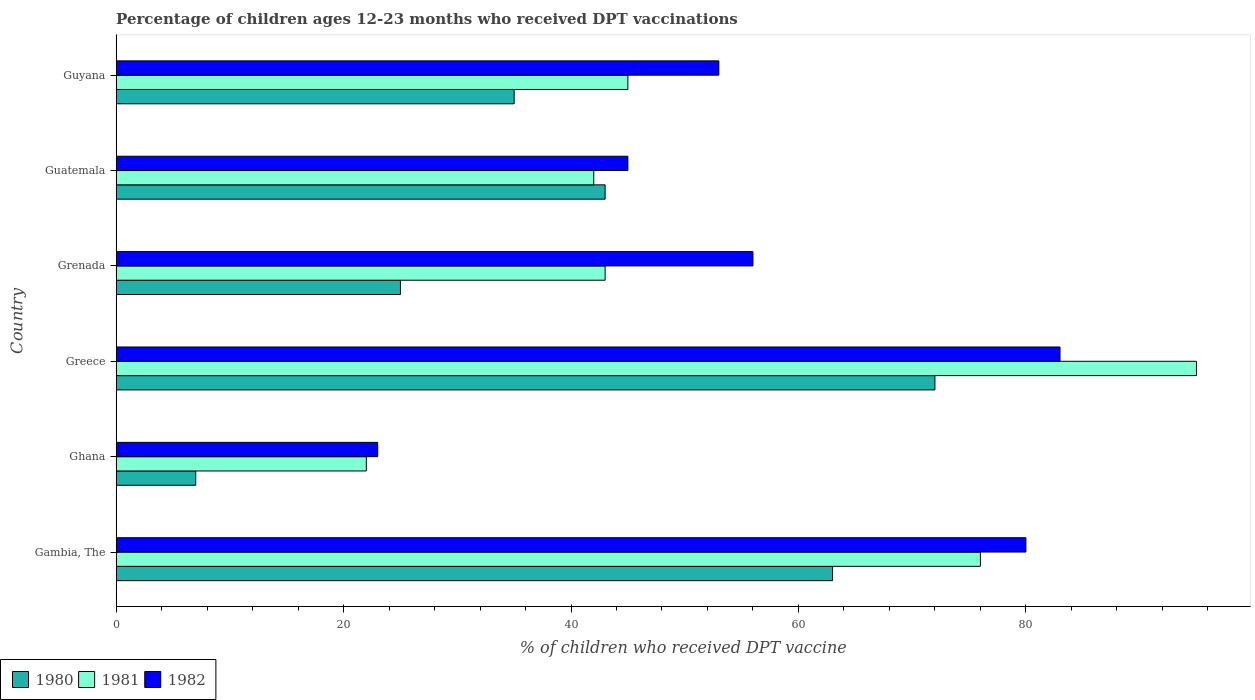How many groups of bars are there?
Make the answer very short. 6. Are the number of bars per tick equal to the number of legend labels?
Your answer should be very brief. Yes. Are the number of bars on each tick of the Y-axis equal?
Keep it short and to the point. Yes. How many bars are there on the 6th tick from the top?
Your answer should be compact. 3. What is the label of the 3rd group of bars from the top?
Give a very brief answer. Grenada. In how many cases, is the number of bars for a given country not equal to the number of legend labels?
Provide a succinct answer. 0. Across all countries, what is the maximum percentage of children who received DPT vaccination in 1982?
Offer a terse response. 83. Across all countries, what is the minimum percentage of children who received DPT vaccination in 1980?
Offer a terse response. 7. In which country was the percentage of children who received DPT vaccination in 1982 minimum?
Offer a terse response. Ghana. What is the total percentage of children who received DPT vaccination in 1980 in the graph?
Ensure brevity in your answer.  245. What is the difference between the percentage of children who received DPT vaccination in 1980 in Guyana and the percentage of children who received DPT vaccination in 1981 in Ghana?
Give a very brief answer. 13. What is the average percentage of children who received DPT vaccination in 1982 per country?
Provide a short and direct response. 56.67. What is the ratio of the percentage of children who received DPT vaccination in 1982 in Greece to that in Guyana?
Your answer should be very brief. 1.57. Is the percentage of children who received DPT vaccination in 1982 in Ghana less than that in Guatemala?
Provide a succinct answer. Yes. Is the difference between the percentage of children who received DPT vaccination in 1982 in Ghana and Greece greater than the difference between the percentage of children who received DPT vaccination in 1980 in Ghana and Greece?
Ensure brevity in your answer.  Yes. What is the difference between the highest and the lowest percentage of children who received DPT vaccination in 1981?
Your response must be concise. 73. In how many countries, is the percentage of children who received DPT vaccination in 1981 greater than the average percentage of children who received DPT vaccination in 1981 taken over all countries?
Your answer should be compact. 2. Is the sum of the percentage of children who received DPT vaccination in 1982 in Gambia, The and Guyana greater than the maximum percentage of children who received DPT vaccination in 1981 across all countries?
Your response must be concise. Yes. What does the 2nd bar from the top in Gambia, The represents?
Your answer should be compact. 1981. What does the 2nd bar from the bottom in Guatemala represents?
Your response must be concise. 1981. Is it the case that in every country, the sum of the percentage of children who received DPT vaccination in 1981 and percentage of children who received DPT vaccination in 1982 is greater than the percentage of children who received DPT vaccination in 1980?
Your response must be concise. Yes. How many bars are there?
Keep it short and to the point. 18. Are all the bars in the graph horizontal?
Make the answer very short. Yes. What is the difference between two consecutive major ticks on the X-axis?
Give a very brief answer. 20. Are the values on the major ticks of X-axis written in scientific E-notation?
Ensure brevity in your answer.  No. How are the legend labels stacked?
Provide a succinct answer. Horizontal. What is the title of the graph?
Your answer should be compact. Percentage of children ages 12-23 months who received DPT vaccinations. What is the label or title of the X-axis?
Your answer should be very brief. % of children who received DPT vaccine. What is the label or title of the Y-axis?
Provide a short and direct response. Country. What is the % of children who received DPT vaccine of 1981 in Gambia, The?
Offer a terse response. 76. What is the % of children who received DPT vaccine in 1982 in Gambia, The?
Provide a succinct answer. 80. What is the % of children who received DPT vaccine in 1980 in Ghana?
Make the answer very short. 7. What is the % of children who received DPT vaccine in 1981 in Ghana?
Keep it short and to the point. 22. What is the % of children who received DPT vaccine of 1982 in Ghana?
Offer a very short reply. 23. What is the % of children who received DPT vaccine in 1980 in Greece?
Your answer should be compact. 72. What is the % of children who received DPT vaccine in 1982 in Greece?
Give a very brief answer. 83. What is the % of children who received DPT vaccine of 1980 in Guatemala?
Your answer should be very brief. 43. What is the % of children who received DPT vaccine of 1982 in Guatemala?
Make the answer very short. 45. What is the % of children who received DPT vaccine in 1980 in Guyana?
Ensure brevity in your answer.  35. What is the % of children who received DPT vaccine in 1982 in Guyana?
Make the answer very short. 53. Across all countries, what is the maximum % of children who received DPT vaccine in 1980?
Offer a terse response. 72. Across all countries, what is the minimum % of children who received DPT vaccine of 1980?
Provide a succinct answer. 7. Across all countries, what is the minimum % of children who received DPT vaccine of 1981?
Keep it short and to the point. 22. Across all countries, what is the minimum % of children who received DPT vaccine in 1982?
Your answer should be compact. 23. What is the total % of children who received DPT vaccine in 1980 in the graph?
Provide a short and direct response. 245. What is the total % of children who received DPT vaccine of 1981 in the graph?
Make the answer very short. 323. What is the total % of children who received DPT vaccine of 1982 in the graph?
Ensure brevity in your answer.  340. What is the difference between the % of children who received DPT vaccine of 1980 in Gambia, The and that in Ghana?
Make the answer very short. 56. What is the difference between the % of children who received DPT vaccine of 1982 in Gambia, The and that in Ghana?
Ensure brevity in your answer.  57. What is the difference between the % of children who received DPT vaccine in 1982 in Gambia, The and that in Grenada?
Provide a short and direct response. 24. What is the difference between the % of children who received DPT vaccine in 1980 in Gambia, The and that in Guatemala?
Make the answer very short. 20. What is the difference between the % of children who received DPT vaccine in 1981 in Gambia, The and that in Guatemala?
Make the answer very short. 34. What is the difference between the % of children who received DPT vaccine in 1980 in Gambia, The and that in Guyana?
Your answer should be compact. 28. What is the difference between the % of children who received DPT vaccine of 1980 in Ghana and that in Greece?
Make the answer very short. -65. What is the difference between the % of children who received DPT vaccine of 1981 in Ghana and that in Greece?
Keep it short and to the point. -73. What is the difference between the % of children who received DPT vaccine in 1982 in Ghana and that in Greece?
Provide a succinct answer. -60. What is the difference between the % of children who received DPT vaccine in 1980 in Ghana and that in Grenada?
Provide a short and direct response. -18. What is the difference between the % of children who received DPT vaccine of 1981 in Ghana and that in Grenada?
Offer a terse response. -21. What is the difference between the % of children who received DPT vaccine in 1982 in Ghana and that in Grenada?
Your answer should be compact. -33. What is the difference between the % of children who received DPT vaccine in 1980 in Ghana and that in Guatemala?
Give a very brief answer. -36. What is the difference between the % of children who received DPT vaccine in 1981 in Ghana and that in Guatemala?
Your answer should be compact. -20. What is the difference between the % of children who received DPT vaccine in 1982 in Ghana and that in Guatemala?
Keep it short and to the point. -22. What is the difference between the % of children who received DPT vaccine of 1980 in Ghana and that in Guyana?
Keep it short and to the point. -28. What is the difference between the % of children who received DPT vaccine in 1981 in Ghana and that in Guyana?
Make the answer very short. -23. What is the difference between the % of children who received DPT vaccine in 1981 in Greece and that in Grenada?
Provide a short and direct response. 52. What is the difference between the % of children who received DPT vaccine in 1982 in Greece and that in Guatemala?
Your response must be concise. 38. What is the difference between the % of children who received DPT vaccine of 1980 in Grenada and that in Guatemala?
Your answer should be compact. -18. What is the difference between the % of children who received DPT vaccine of 1982 in Grenada and that in Guatemala?
Your answer should be very brief. 11. What is the difference between the % of children who received DPT vaccine of 1981 in Grenada and that in Guyana?
Your answer should be compact. -2. What is the difference between the % of children who received DPT vaccine in 1982 in Grenada and that in Guyana?
Your answer should be compact. 3. What is the difference between the % of children who received DPT vaccine in 1980 in Guatemala and that in Guyana?
Your response must be concise. 8. What is the difference between the % of children who received DPT vaccine in 1982 in Guatemala and that in Guyana?
Make the answer very short. -8. What is the difference between the % of children who received DPT vaccine of 1980 in Gambia, The and the % of children who received DPT vaccine of 1981 in Greece?
Provide a succinct answer. -32. What is the difference between the % of children who received DPT vaccine in 1980 in Gambia, The and the % of children who received DPT vaccine in 1981 in Grenada?
Your answer should be compact. 20. What is the difference between the % of children who received DPT vaccine of 1980 in Gambia, The and the % of children who received DPT vaccine of 1982 in Grenada?
Provide a succinct answer. 7. What is the difference between the % of children who received DPT vaccine in 1981 in Gambia, The and the % of children who received DPT vaccine in 1982 in Grenada?
Make the answer very short. 20. What is the difference between the % of children who received DPT vaccine of 1980 in Gambia, The and the % of children who received DPT vaccine of 1982 in Guyana?
Your answer should be very brief. 10. What is the difference between the % of children who received DPT vaccine in 1981 in Gambia, The and the % of children who received DPT vaccine in 1982 in Guyana?
Your answer should be compact. 23. What is the difference between the % of children who received DPT vaccine of 1980 in Ghana and the % of children who received DPT vaccine of 1981 in Greece?
Provide a short and direct response. -88. What is the difference between the % of children who received DPT vaccine of 1980 in Ghana and the % of children who received DPT vaccine of 1982 in Greece?
Provide a succinct answer. -76. What is the difference between the % of children who received DPT vaccine in 1981 in Ghana and the % of children who received DPT vaccine in 1982 in Greece?
Offer a very short reply. -61. What is the difference between the % of children who received DPT vaccine in 1980 in Ghana and the % of children who received DPT vaccine in 1981 in Grenada?
Keep it short and to the point. -36. What is the difference between the % of children who received DPT vaccine in 1980 in Ghana and the % of children who received DPT vaccine in 1982 in Grenada?
Give a very brief answer. -49. What is the difference between the % of children who received DPT vaccine of 1981 in Ghana and the % of children who received DPT vaccine of 1982 in Grenada?
Provide a short and direct response. -34. What is the difference between the % of children who received DPT vaccine of 1980 in Ghana and the % of children who received DPT vaccine of 1981 in Guatemala?
Provide a short and direct response. -35. What is the difference between the % of children who received DPT vaccine in 1980 in Ghana and the % of children who received DPT vaccine in 1982 in Guatemala?
Your answer should be compact. -38. What is the difference between the % of children who received DPT vaccine in 1980 in Ghana and the % of children who received DPT vaccine in 1981 in Guyana?
Ensure brevity in your answer.  -38. What is the difference between the % of children who received DPT vaccine in 1980 in Ghana and the % of children who received DPT vaccine in 1982 in Guyana?
Make the answer very short. -46. What is the difference between the % of children who received DPT vaccine in 1981 in Ghana and the % of children who received DPT vaccine in 1982 in Guyana?
Provide a short and direct response. -31. What is the difference between the % of children who received DPT vaccine of 1981 in Greece and the % of children who received DPT vaccine of 1982 in Grenada?
Provide a succinct answer. 39. What is the difference between the % of children who received DPT vaccine in 1980 in Greece and the % of children who received DPT vaccine in 1981 in Guatemala?
Provide a succinct answer. 30. What is the difference between the % of children who received DPT vaccine of 1980 in Greece and the % of children who received DPT vaccine of 1982 in Guatemala?
Your response must be concise. 27. What is the difference between the % of children who received DPT vaccine in 1980 in Greece and the % of children who received DPT vaccine in 1982 in Guyana?
Make the answer very short. 19. What is the difference between the % of children who received DPT vaccine in 1980 in Grenada and the % of children who received DPT vaccine in 1982 in Guatemala?
Your response must be concise. -20. What is the difference between the % of children who received DPT vaccine of 1981 in Grenada and the % of children who received DPT vaccine of 1982 in Guatemala?
Give a very brief answer. -2. What is the difference between the % of children who received DPT vaccine of 1980 in Grenada and the % of children who received DPT vaccine of 1981 in Guyana?
Your answer should be compact. -20. What is the difference between the % of children who received DPT vaccine of 1980 in Grenada and the % of children who received DPT vaccine of 1982 in Guyana?
Your answer should be very brief. -28. What is the difference between the % of children who received DPT vaccine of 1981 in Grenada and the % of children who received DPT vaccine of 1982 in Guyana?
Make the answer very short. -10. What is the average % of children who received DPT vaccine of 1980 per country?
Your answer should be compact. 40.83. What is the average % of children who received DPT vaccine in 1981 per country?
Ensure brevity in your answer.  53.83. What is the average % of children who received DPT vaccine of 1982 per country?
Your answer should be very brief. 56.67. What is the difference between the % of children who received DPT vaccine of 1981 and % of children who received DPT vaccine of 1982 in Gambia, The?
Provide a succinct answer. -4. What is the difference between the % of children who received DPT vaccine of 1980 and % of children who received DPT vaccine of 1982 in Ghana?
Provide a short and direct response. -16. What is the difference between the % of children who received DPT vaccine in 1980 and % of children who received DPT vaccine in 1981 in Greece?
Offer a terse response. -23. What is the difference between the % of children who received DPT vaccine of 1980 and % of children who received DPT vaccine of 1982 in Grenada?
Provide a succinct answer. -31. What is the difference between the % of children who received DPT vaccine of 1980 and % of children who received DPT vaccine of 1981 in Guatemala?
Your response must be concise. 1. What is the difference between the % of children who received DPT vaccine of 1981 and % of children who received DPT vaccine of 1982 in Guyana?
Keep it short and to the point. -8. What is the ratio of the % of children who received DPT vaccine of 1981 in Gambia, The to that in Ghana?
Offer a very short reply. 3.45. What is the ratio of the % of children who received DPT vaccine of 1982 in Gambia, The to that in Ghana?
Make the answer very short. 3.48. What is the ratio of the % of children who received DPT vaccine in 1981 in Gambia, The to that in Greece?
Keep it short and to the point. 0.8. What is the ratio of the % of children who received DPT vaccine in 1982 in Gambia, The to that in Greece?
Make the answer very short. 0.96. What is the ratio of the % of children who received DPT vaccine of 1980 in Gambia, The to that in Grenada?
Provide a short and direct response. 2.52. What is the ratio of the % of children who received DPT vaccine in 1981 in Gambia, The to that in Grenada?
Your answer should be very brief. 1.77. What is the ratio of the % of children who received DPT vaccine of 1982 in Gambia, The to that in Grenada?
Provide a succinct answer. 1.43. What is the ratio of the % of children who received DPT vaccine of 1980 in Gambia, The to that in Guatemala?
Keep it short and to the point. 1.47. What is the ratio of the % of children who received DPT vaccine of 1981 in Gambia, The to that in Guatemala?
Give a very brief answer. 1.81. What is the ratio of the % of children who received DPT vaccine in 1982 in Gambia, The to that in Guatemala?
Your answer should be very brief. 1.78. What is the ratio of the % of children who received DPT vaccine of 1981 in Gambia, The to that in Guyana?
Your answer should be compact. 1.69. What is the ratio of the % of children who received DPT vaccine in 1982 in Gambia, The to that in Guyana?
Ensure brevity in your answer.  1.51. What is the ratio of the % of children who received DPT vaccine of 1980 in Ghana to that in Greece?
Offer a terse response. 0.1. What is the ratio of the % of children who received DPT vaccine of 1981 in Ghana to that in Greece?
Your response must be concise. 0.23. What is the ratio of the % of children who received DPT vaccine in 1982 in Ghana to that in Greece?
Provide a succinct answer. 0.28. What is the ratio of the % of children who received DPT vaccine of 1980 in Ghana to that in Grenada?
Make the answer very short. 0.28. What is the ratio of the % of children who received DPT vaccine of 1981 in Ghana to that in Grenada?
Your answer should be very brief. 0.51. What is the ratio of the % of children who received DPT vaccine in 1982 in Ghana to that in Grenada?
Offer a terse response. 0.41. What is the ratio of the % of children who received DPT vaccine of 1980 in Ghana to that in Guatemala?
Ensure brevity in your answer.  0.16. What is the ratio of the % of children who received DPT vaccine of 1981 in Ghana to that in Guatemala?
Your response must be concise. 0.52. What is the ratio of the % of children who received DPT vaccine of 1982 in Ghana to that in Guatemala?
Your answer should be compact. 0.51. What is the ratio of the % of children who received DPT vaccine of 1980 in Ghana to that in Guyana?
Your response must be concise. 0.2. What is the ratio of the % of children who received DPT vaccine in 1981 in Ghana to that in Guyana?
Your answer should be compact. 0.49. What is the ratio of the % of children who received DPT vaccine in 1982 in Ghana to that in Guyana?
Offer a very short reply. 0.43. What is the ratio of the % of children who received DPT vaccine of 1980 in Greece to that in Grenada?
Offer a terse response. 2.88. What is the ratio of the % of children who received DPT vaccine in 1981 in Greece to that in Grenada?
Provide a succinct answer. 2.21. What is the ratio of the % of children who received DPT vaccine in 1982 in Greece to that in Grenada?
Provide a succinct answer. 1.48. What is the ratio of the % of children who received DPT vaccine of 1980 in Greece to that in Guatemala?
Keep it short and to the point. 1.67. What is the ratio of the % of children who received DPT vaccine in 1981 in Greece to that in Guatemala?
Offer a terse response. 2.26. What is the ratio of the % of children who received DPT vaccine in 1982 in Greece to that in Guatemala?
Make the answer very short. 1.84. What is the ratio of the % of children who received DPT vaccine of 1980 in Greece to that in Guyana?
Give a very brief answer. 2.06. What is the ratio of the % of children who received DPT vaccine in 1981 in Greece to that in Guyana?
Provide a short and direct response. 2.11. What is the ratio of the % of children who received DPT vaccine in 1982 in Greece to that in Guyana?
Ensure brevity in your answer.  1.57. What is the ratio of the % of children who received DPT vaccine of 1980 in Grenada to that in Guatemala?
Provide a succinct answer. 0.58. What is the ratio of the % of children who received DPT vaccine in 1981 in Grenada to that in Guatemala?
Offer a terse response. 1.02. What is the ratio of the % of children who received DPT vaccine in 1982 in Grenada to that in Guatemala?
Your answer should be very brief. 1.24. What is the ratio of the % of children who received DPT vaccine in 1981 in Grenada to that in Guyana?
Your response must be concise. 0.96. What is the ratio of the % of children who received DPT vaccine in 1982 in Grenada to that in Guyana?
Your response must be concise. 1.06. What is the ratio of the % of children who received DPT vaccine in 1980 in Guatemala to that in Guyana?
Ensure brevity in your answer.  1.23. What is the ratio of the % of children who received DPT vaccine in 1981 in Guatemala to that in Guyana?
Your answer should be very brief. 0.93. What is the ratio of the % of children who received DPT vaccine in 1982 in Guatemala to that in Guyana?
Give a very brief answer. 0.85. What is the difference between the highest and the second highest % of children who received DPT vaccine in 1981?
Your response must be concise. 19. What is the difference between the highest and the second highest % of children who received DPT vaccine in 1982?
Offer a very short reply. 3. 